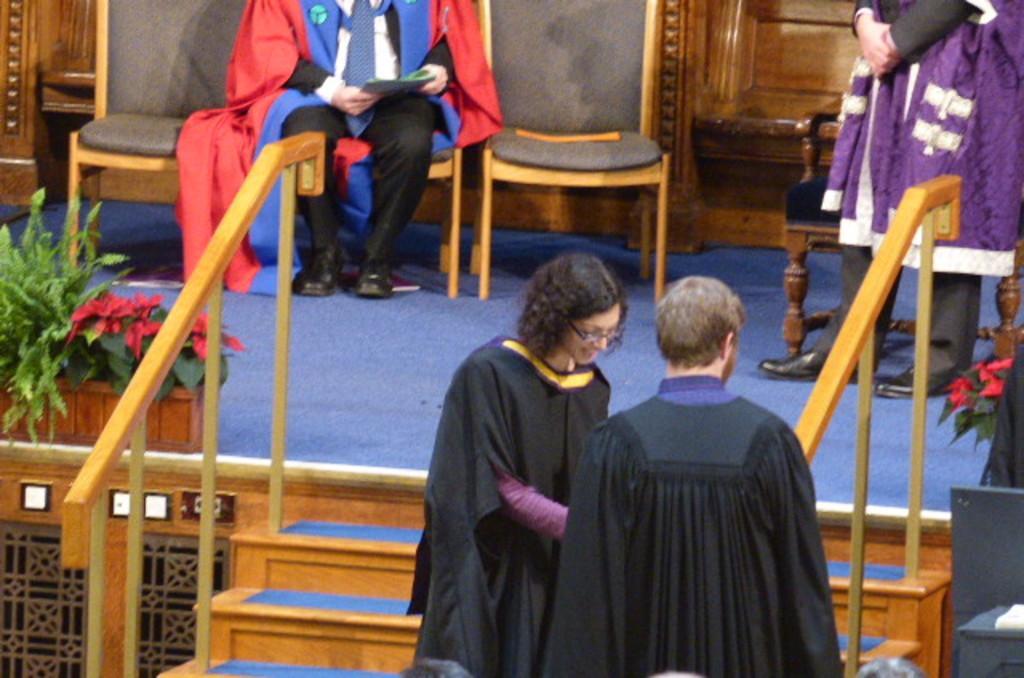Describe this image in one or two sentences. As we can see in the image there are stairs, plants, flowers, few people here and there and chairs. 